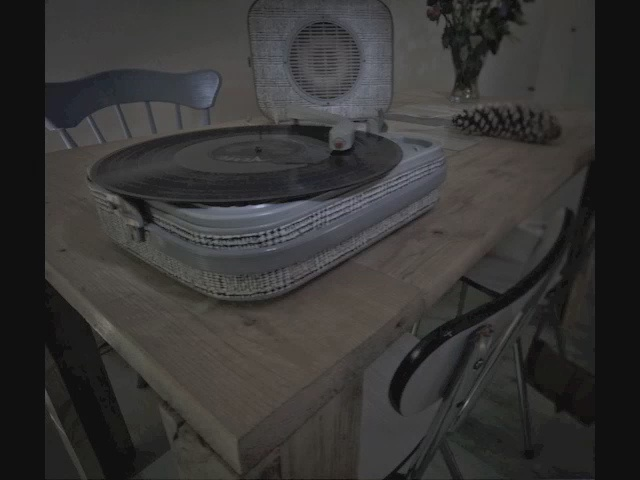Describe the objects in this image and their specific colors. I can see dining table in black and gray tones, chair in black tones, chair in black and gray tones, chair in black tones, and vase in black and gray tones in this image. 